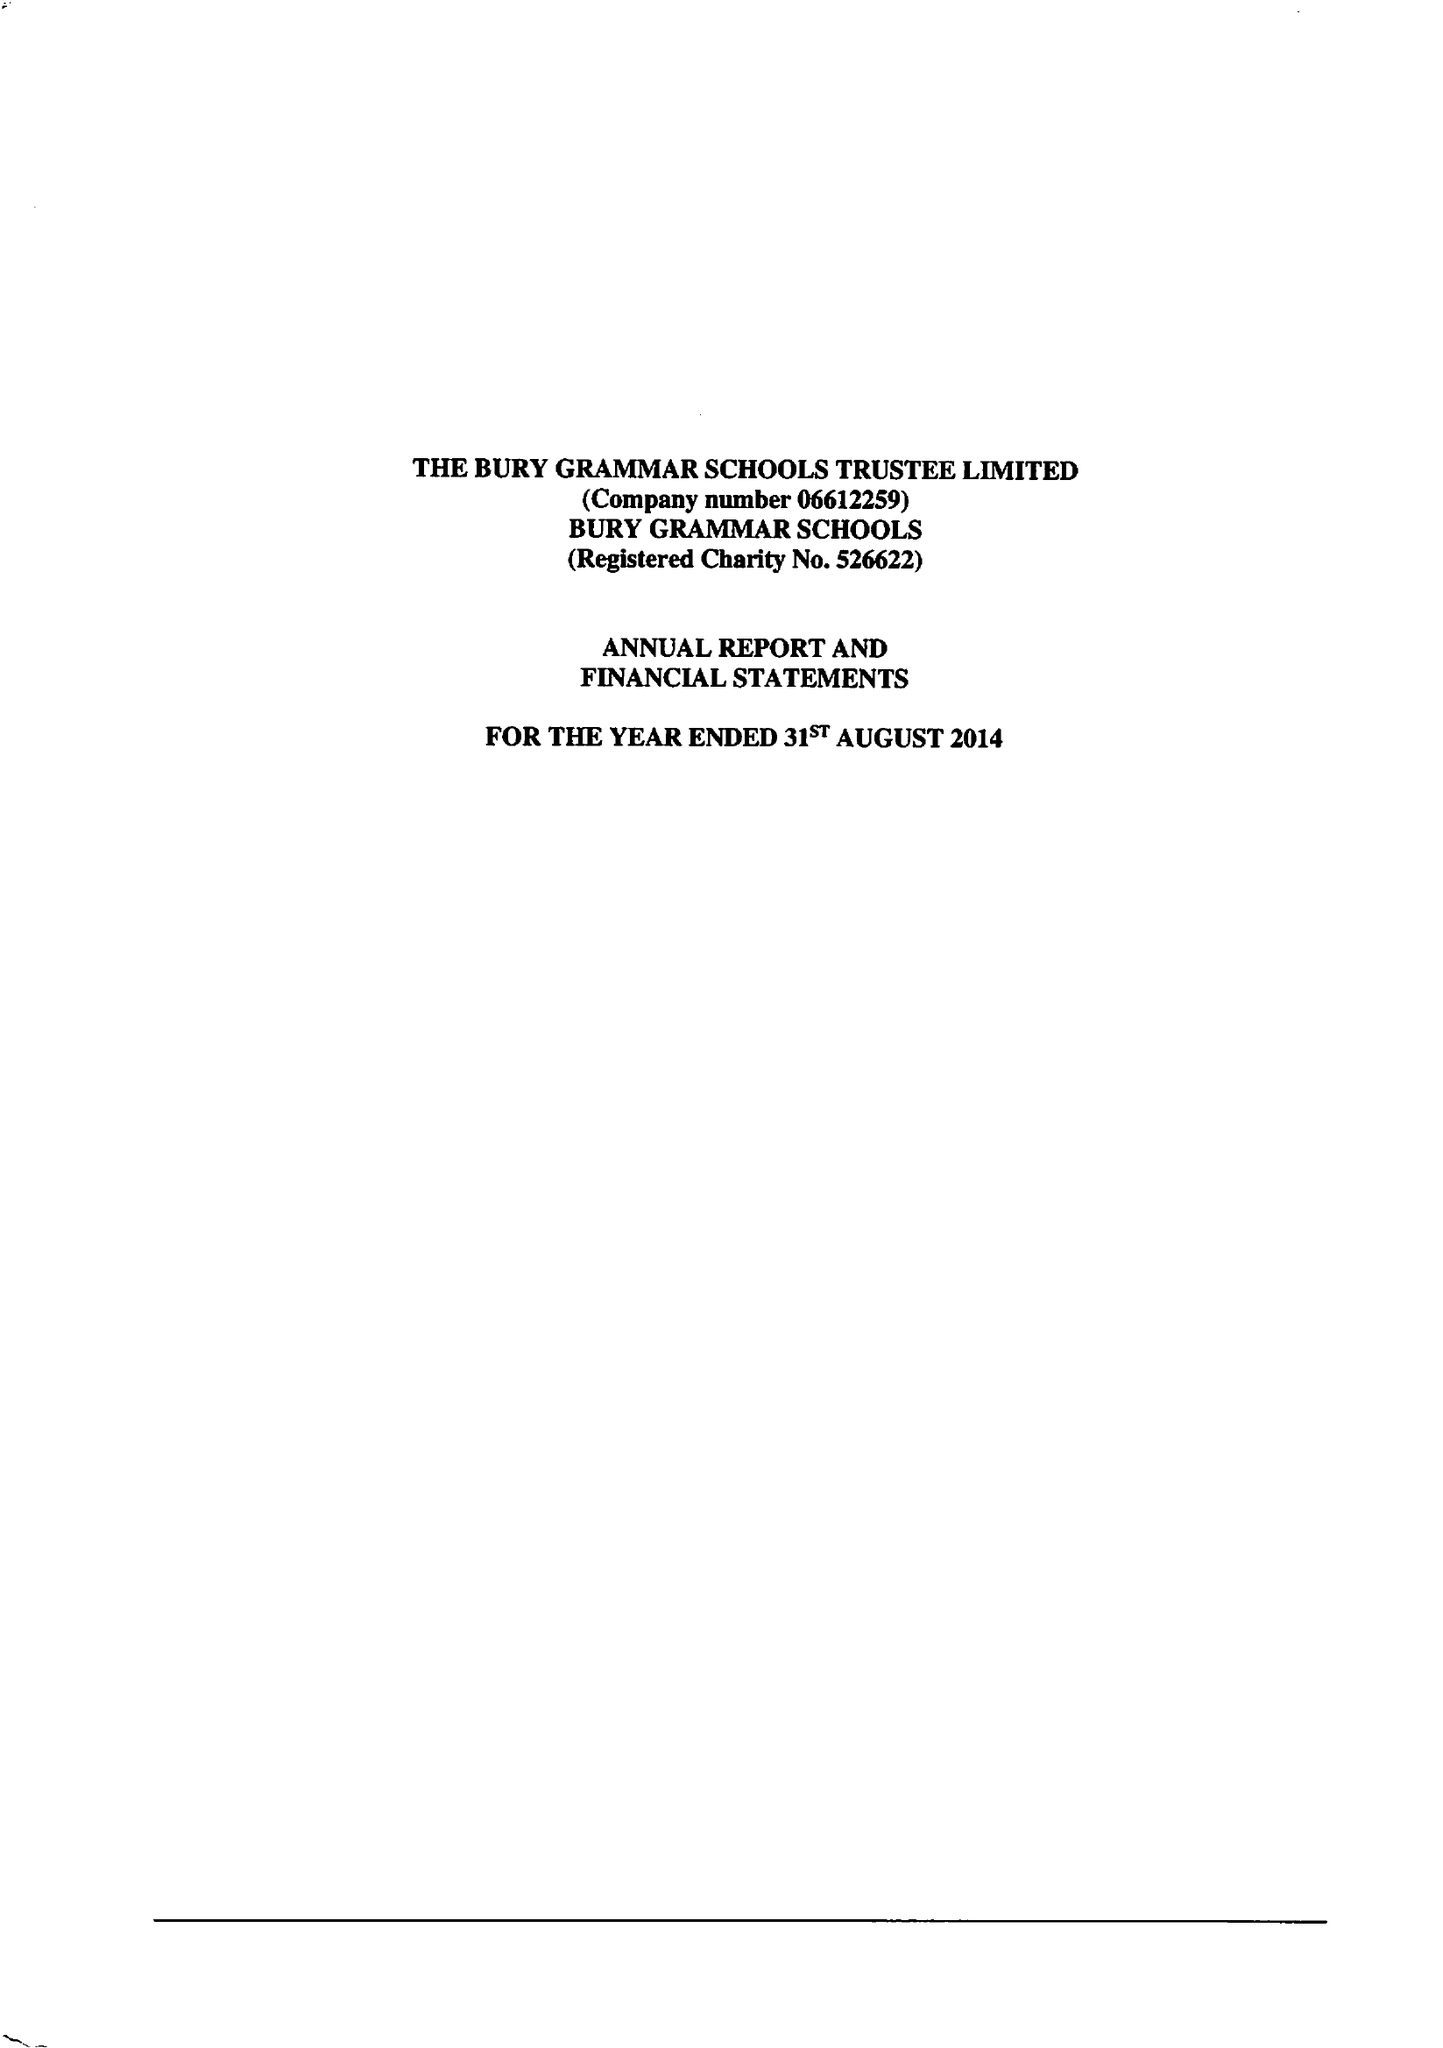What is the value for the charity_number?
Answer the question using a single word or phrase. 526622 